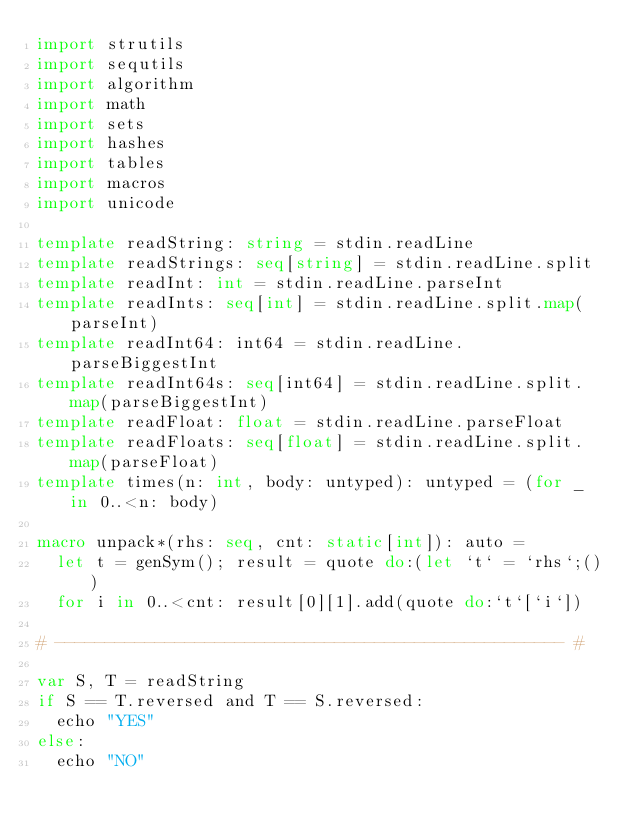Convert code to text. <code><loc_0><loc_0><loc_500><loc_500><_Nim_>import strutils
import sequtils
import algorithm
import math
import sets
import hashes
import tables
import macros
import unicode

template readString: string = stdin.readLine
template readStrings: seq[string] = stdin.readLine.split
template readInt: int = stdin.readLine.parseInt
template readInts: seq[int] = stdin.readLine.split.map(parseInt)
template readInt64: int64 = stdin.readLine.parseBiggestInt
template readInt64s: seq[int64] = stdin.readLine.split.map(parseBiggestInt)
template readFloat: float = stdin.readLine.parseFloat
template readFloats: seq[float] = stdin.readLine.split.map(parseFloat)
template times(n: int, body: untyped): untyped = (for _ in 0..<n: body)

macro unpack*(rhs: seq, cnt: static[int]): auto =
  let t = genSym(); result = quote do:(let `t` = `rhs`;())
  for i in 0..<cnt: result[0][1].add(quote do:`t`[`i`])

# --------------------------------------------------- #

var S, T = readString
if S == T.reversed and T == S.reversed:
  echo "YES"
else:
  echo "NO"</code> 